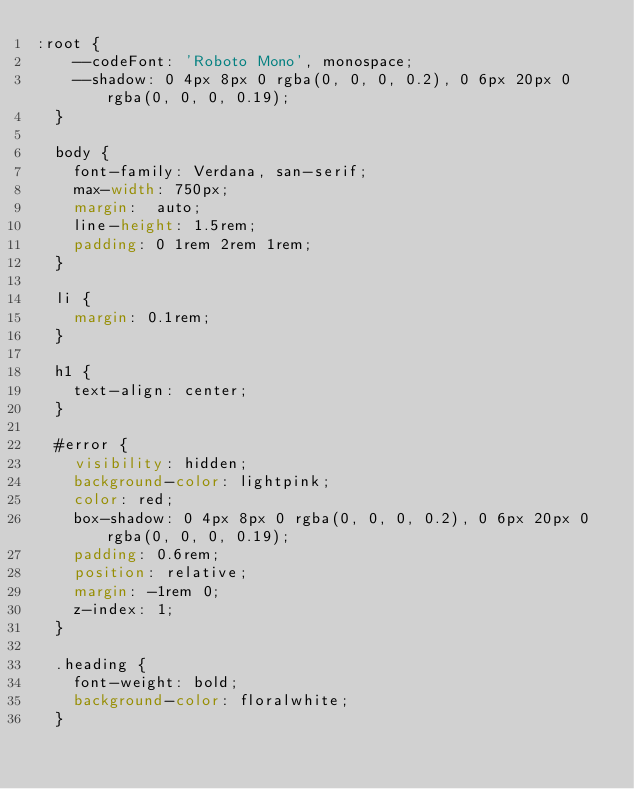<code> <loc_0><loc_0><loc_500><loc_500><_CSS_>:root {
    --codeFont: 'Roboto Mono', monospace;
    --shadow: 0 4px 8px 0 rgba(0, 0, 0, 0.2), 0 6px 20px 0 rgba(0, 0, 0, 0.19);
  }

  body {
    font-family: Verdana, san-serif;
    max-width: 750px;
    margin:  auto;
    line-height: 1.5rem;
    padding: 0 1rem 2rem 1rem;
  }

  li {
    margin: 0.1rem;
  }

  h1 {
    text-align: center;
  }

  #error {
    visibility: hidden;
    background-color: lightpink;
    color: red;
    box-shadow: 0 4px 8px 0 rgba(0, 0, 0, 0.2), 0 6px 20px 0 rgba(0, 0, 0, 0.19);
    padding: 0.6rem;
    position: relative;
    margin: -1rem 0;
    z-index: 1;
  }

  .heading {
    font-weight: bold;
    background-color: floralwhite;
  }
</code> 